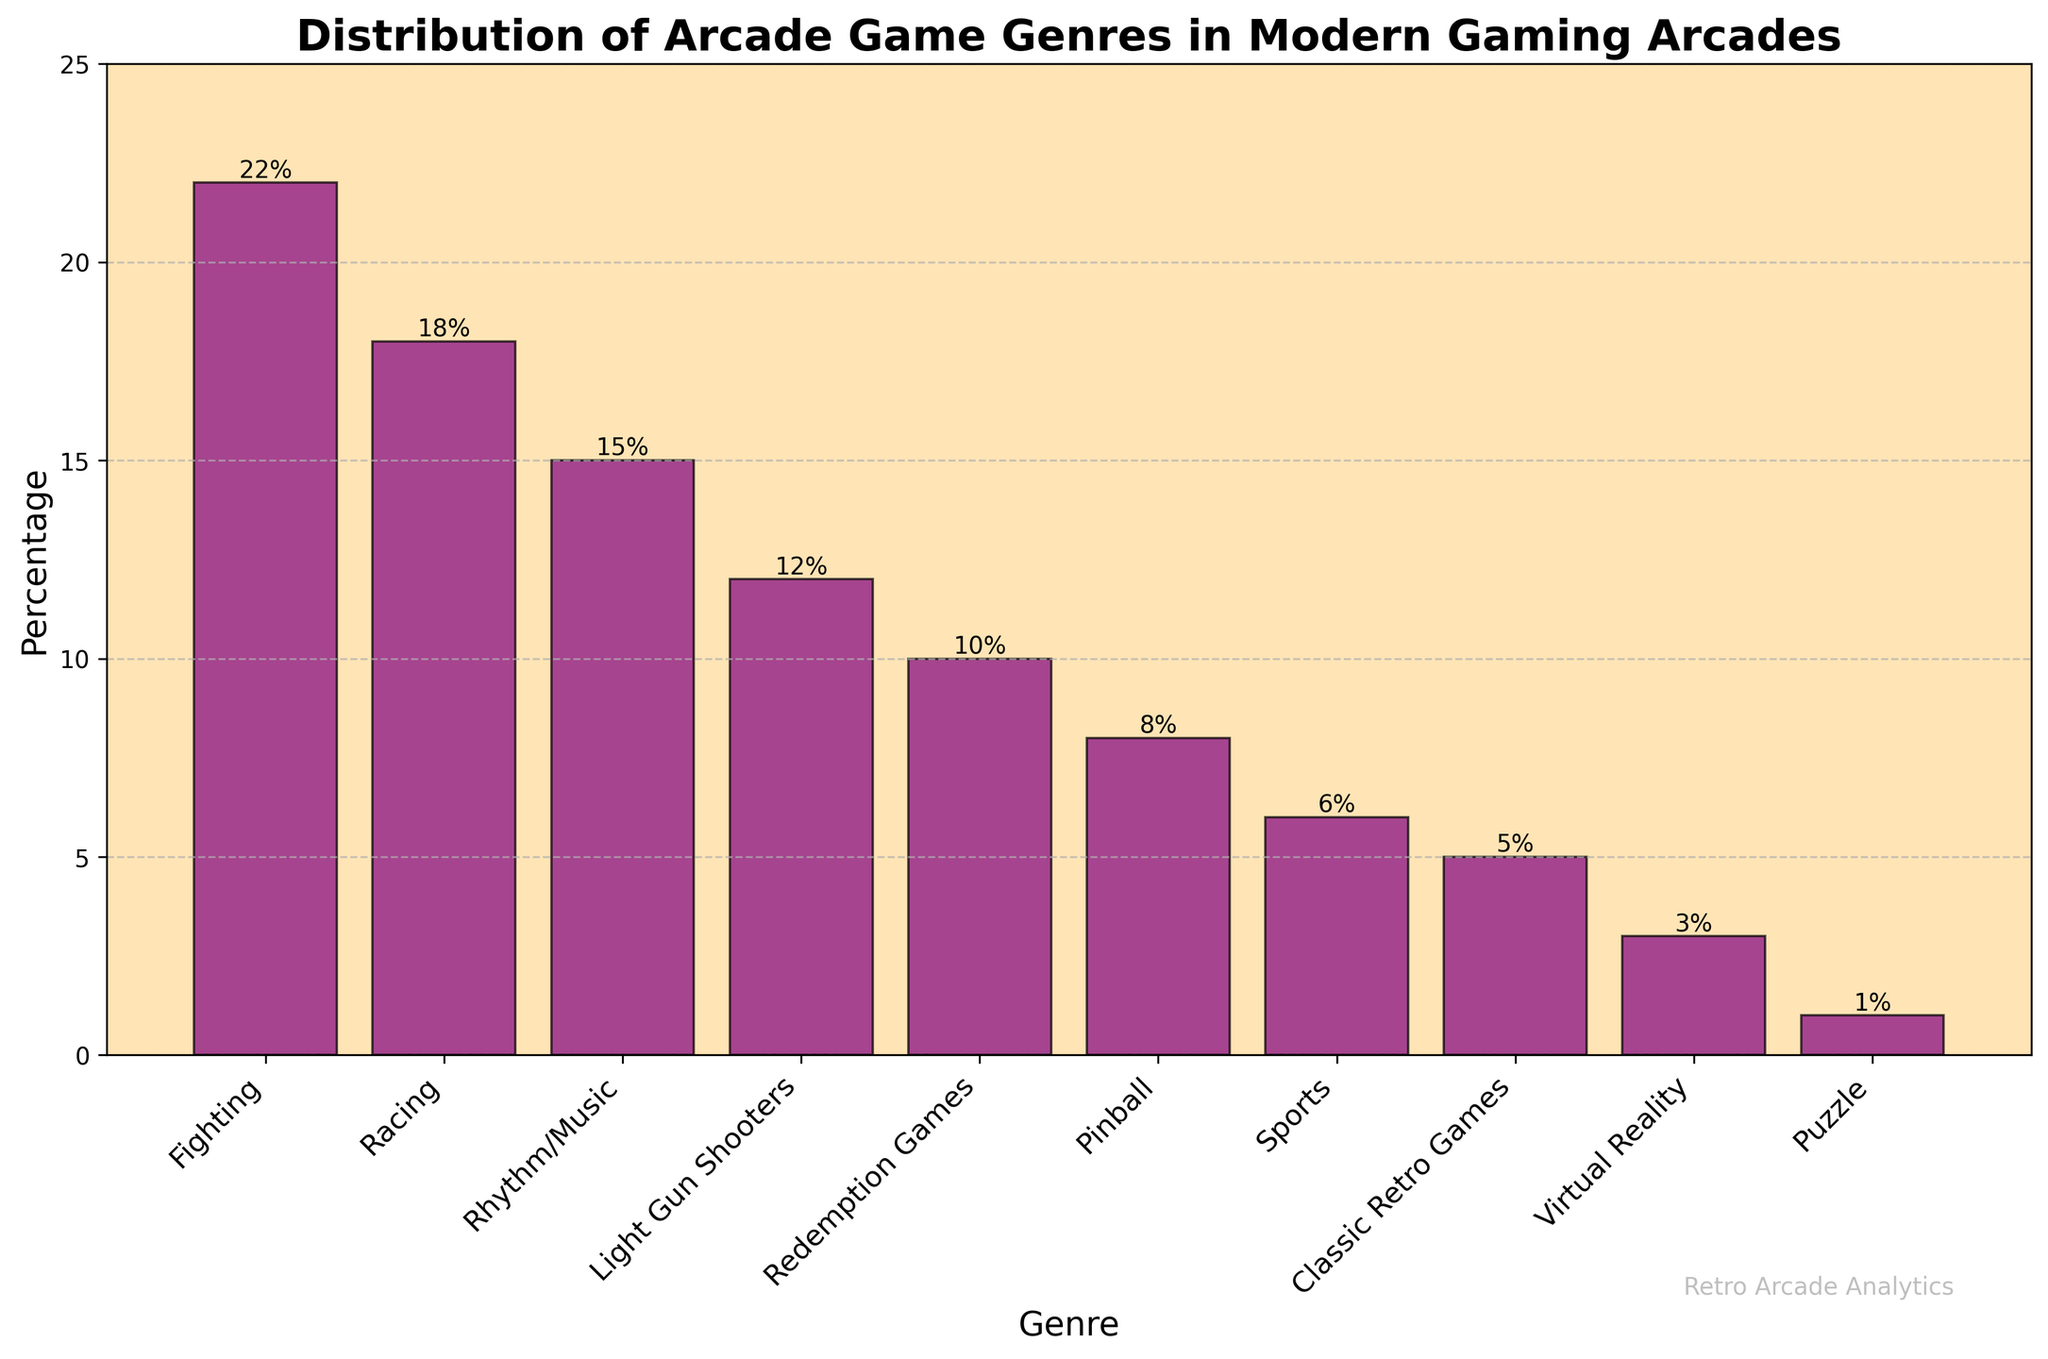What's the most popular arcade game genre in modern gaming arcades? The bar representing the 'Fighting' genre is the tallest, indicating the highest percentage.
Answer: Fighting Which genres have a percentage below 10%? Bars for the genres 'Redemption Games', 'Pinball', 'Sports', 'Classic Retro Games', 'Virtual Reality', and 'Puzzle' are below the 10% mark.
Answer: Redemption Games, Pinball, Sports, Classic Retro Games, Virtual Reality, Puzzle How much more popular is the Fighting genre compared to the Classic Retro Games genre? Fighting has a percentage of 22% while Classic Retro Games have 5%. The difference is 22% - 5% = 17%.
Answer: 17% What's the total percentage of all genres combined? Adding up all the percentages: 22 + 18 + 15 + 12 + 10 + 8 + 6 + 5 + 3 + 1 = 100%.
Answer: 100% If the percentage of Racing games increased by 5%, what would it be? The current percentage for Racing is 18%. If it increased by 5%, it would be 18% + 5% = 23%.
Answer: 23% Which genre has the smallest percentage and what is it? The 'Puzzle' genre has the shortest bar, indicating the smallest percentage of 1%.
Answer: Puzzle Compare the vertical heights of bars representing Rhythm/Music and Virtual Reality genres. The height of the Rhythm/Music genre bar is 15%, while the Virtual Reality genre bar stands at 3%. Rhythm/Music is 15% - 3% = 12% taller.
Answer: Rhythm/Music is 12% taller By how much does the combined percentage of Racing and Sports genres exceed the percentage of Light Gun Shooters? Racing is 18% and Sports is 6%. Combined, they are 18% + 6% = 24%. Light Gun Shooters stands at 12%. The difference is 24% - 12% = 12%.
Answer: 12% What percentage of the chart is represented by Rhythm/Music and Pinball genres together? The percentages for Rhythm/Music and Pinball are 15% and 8% respectively. Together, they sum up to 15% + 8% = 23%.
Answer: 23% 